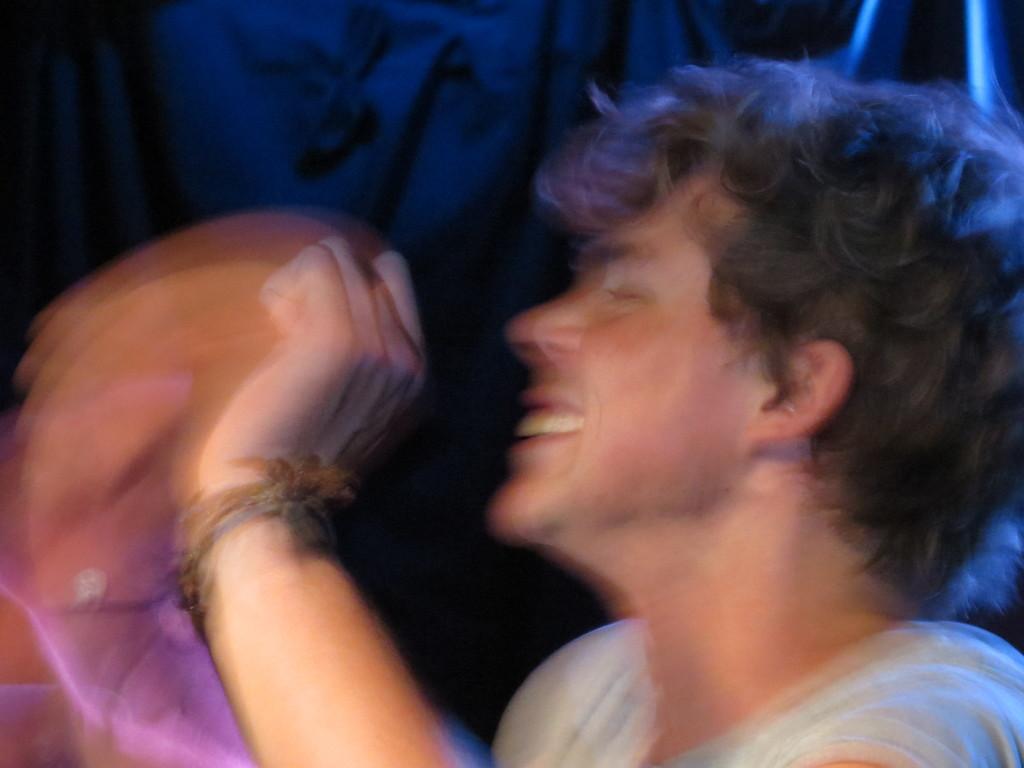How would you summarize this image in a sentence or two? In this picture we can see a blur image of a person. In the background the image is dark. 